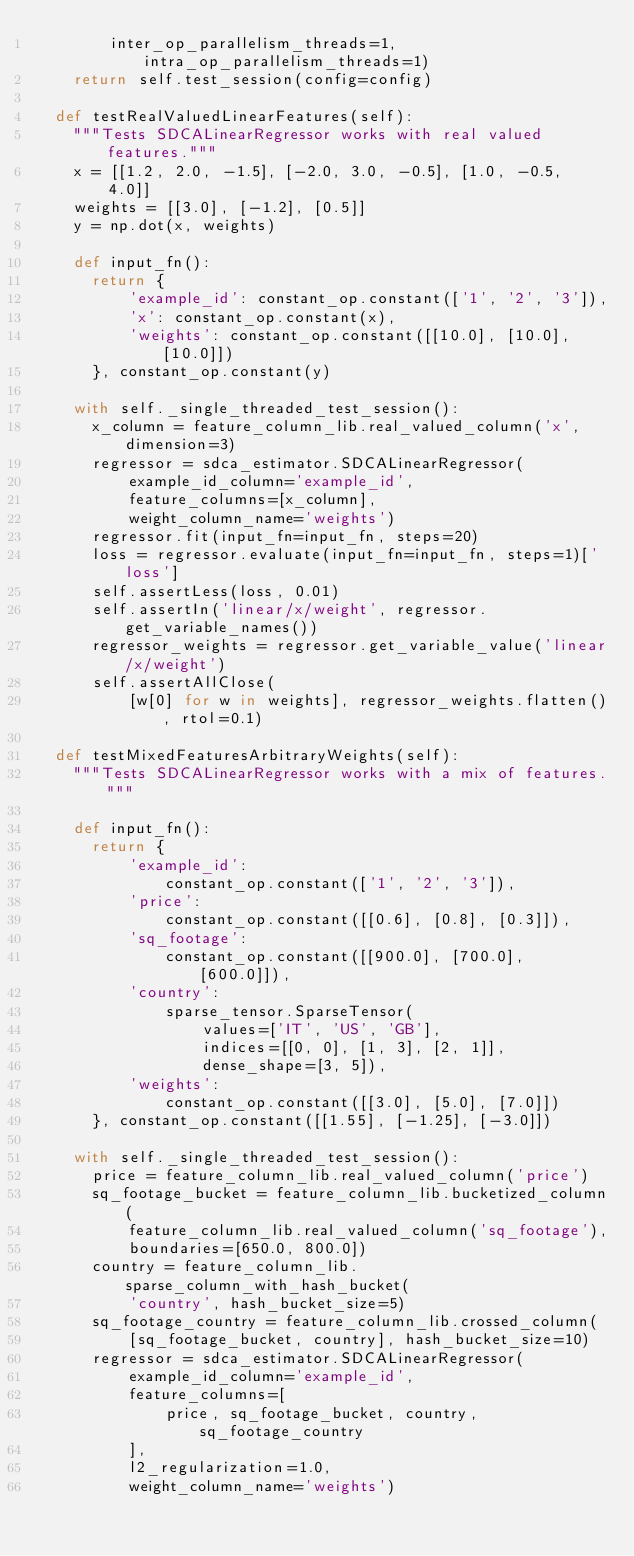<code> <loc_0><loc_0><loc_500><loc_500><_Python_>        inter_op_parallelism_threads=1, intra_op_parallelism_threads=1)
    return self.test_session(config=config)

  def testRealValuedLinearFeatures(self):
    """Tests SDCALinearRegressor works with real valued features."""
    x = [[1.2, 2.0, -1.5], [-2.0, 3.0, -0.5], [1.0, -0.5, 4.0]]
    weights = [[3.0], [-1.2], [0.5]]
    y = np.dot(x, weights)

    def input_fn():
      return {
          'example_id': constant_op.constant(['1', '2', '3']),
          'x': constant_op.constant(x),
          'weights': constant_op.constant([[10.0], [10.0], [10.0]])
      }, constant_op.constant(y)

    with self._single_threaded_test_session():
      x_column = feature_column_lib.real_valued_column('x', dimension=3)
      regressor = sdca_estimator.SDCALinearRegressor(
          example_id_column='example_id',
          feature_columns=[x_column],
          weight_column_name='weights')
      regressor.fit(input_fn=input_fn, steps=20)
      loss = regressor.evaluate(input_fn=input_fn, steps=1)['loss']
      self.assertLess(loss, 0.01)
      self.assertIn('linear/x/weight', regressor.get_variable_names())
      regressor_weights = regressor.get_variable_value('linear/x/weight')
      self.assertAllClose(
          [w[0] for w in weights], regressor_weights.flatten(), rtol=0.1)

  def testMixedFeaturesArbitraryWeights(self):
    """Tests SDCALinearRegressor works with a mix of features."""

    def input_fn():
      return {
          'example_id':
              constant_op.constant(['1', '2', '3']),
          'price':
              constant_op.constant([[0.6], [0.8], [0.3]]),
          'sq_footage':
              constant_op.constant([[900.0], [700.0], [600.0]]),
          'country':
              sparse_tensor.SparseTensor(
                  values=['IT', 'US', 'GB'],
                  indices=[[0, 0], [1, 3], [2, 1]],
                  dense_shape=[3, 5]),
          'weights':
              constant_op.constant([[3.0], [5.0], [7.0]])
      }, constant_op.constant([[1.55], [-1.25], [-3.0]])

    with self._single_threaded_test_session():
      price = feature_column_lib.real_valued_column('price')
      sq_footage_bucket = feature_column_lib.bucketized_column(
          feature_column_lib.real_valued_column('sq_footage'),
          boundaries=[650.0, 800.0])
      country = feature_column_lib.sparse_column_with_hash_bucket(
          'country', hash_bucket_size=5)
      sq_footage_country = feature_column_lib.crossed_column(
          [sq_footage_bucket, country], hash_bucket_size=10)
      regressor = sdca_estimator.SDCALinearRegressor(
          example_id_column='example_id',
          feature_columns=[
              price, sq_footage_bucket, country, sq_footage_country
          ],
          l2_regularization=1.0,
          weight_column_name='weights')</code> 